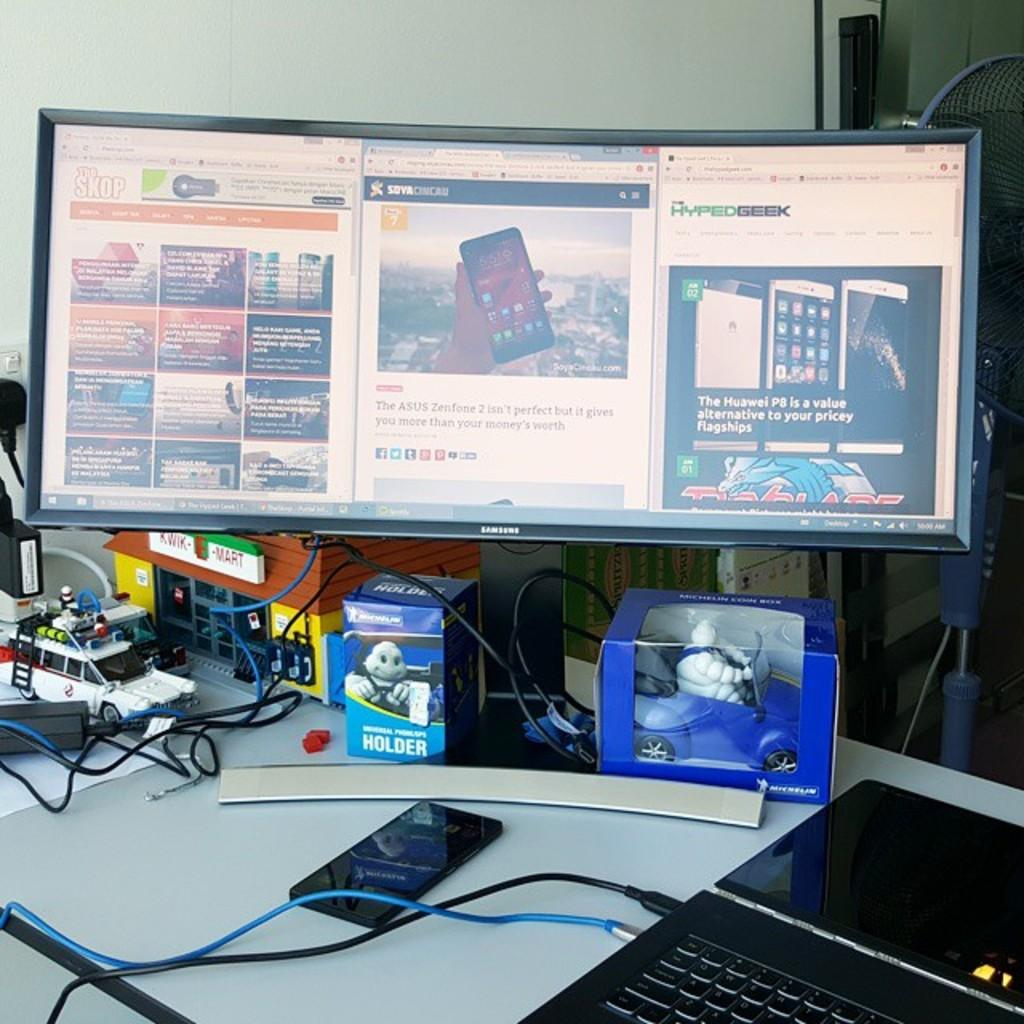<image>
Share a concise interpretation of the image provided. A black samsung monitor displays some phones on it 